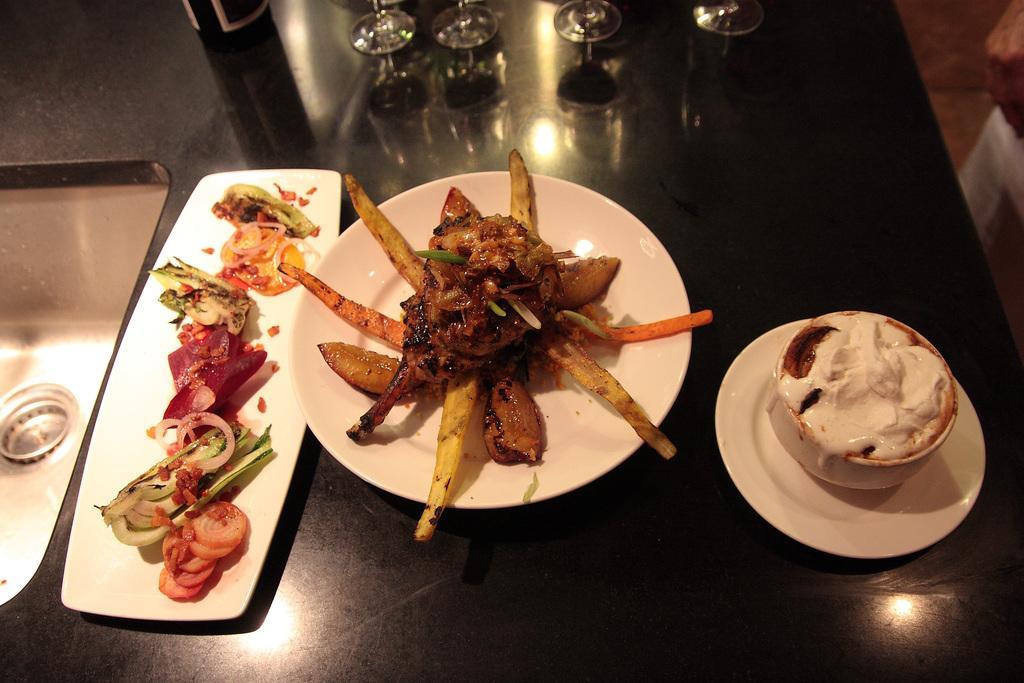Can you describe this image briefly? In this image we can see some containing meat, carrot and potato slices in a plate placed on the table. On the left side we can see some food in tray beside a sink. On the right side we can see an ice cream in a bowl. We can also see some glasses and a bottle on the table. 